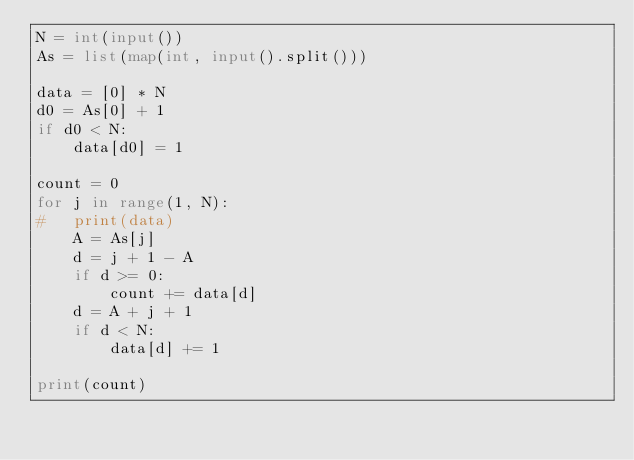Convert code to text. <code><loc_0><loc_0><loc_500><loc_500><_Python_>N = int(input())
As = list(map(int, input().split()))

data = [0] * N
d0 = As[0] + 1
if d0 < N:
	data[d0] = 1

count = 0
for j in range(1, N):
#	print(data)
	A = As[j]
	d = j + 1 - A
	if d >= 0:
		count += data[d]
	d = A + j + 1
	if d < N:
		data[d] += 1

print(count)</code> 